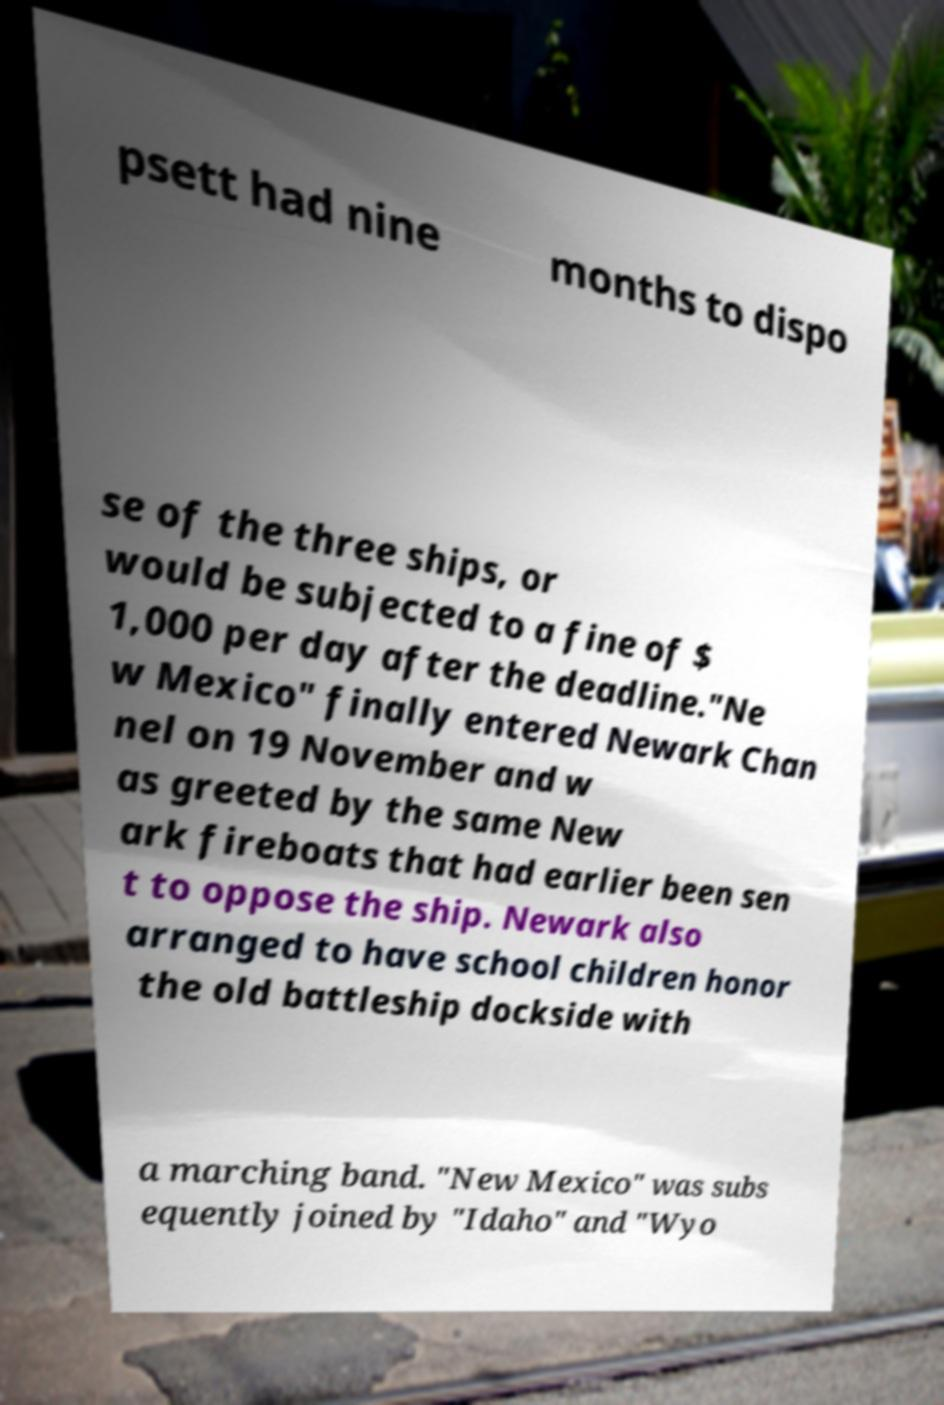Could you assist in decoding the text presented in this image and type it out clearly? psett had nine months to dispo se of the three ships, or would be subjected to a fine of $ 1,000 per day after the deadline."Ne w Mexico" finally entered Newark Chan nel on 19 November and w as greeted by the same New ark fireboats that had earlier been sen t to oppose the ship. Newark also arranged to have school children honor the old battleship dockside with a marching band. "New Mexico" was subs equently joined by "Idaho" and "Wyo 